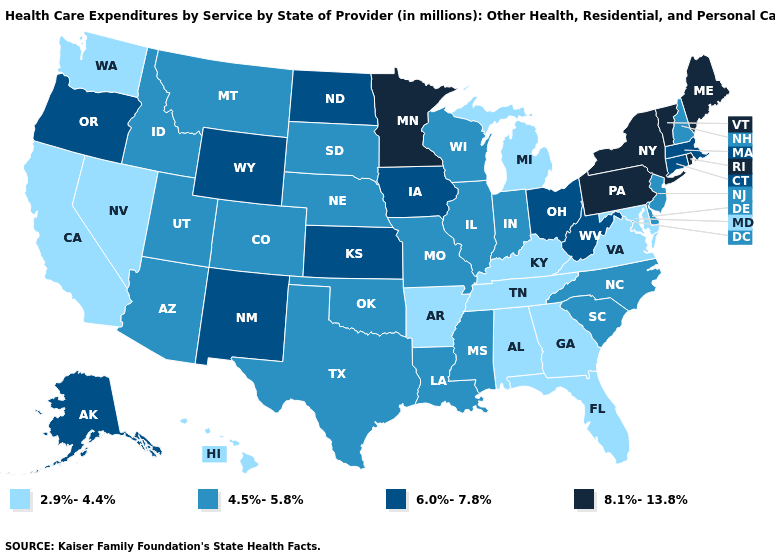What is the value of Hawaii?
Write a very short answer. 2.9%-4.4%. What is the value of Hawaii?
Quick response, please. 2.9%-4.4%. What is the value of North Carolina?
Be succinct. 4.5%-5.8%. Among the states that border California , does Arizona have the highest value?
Give a very brief answer. No. Does Arkansas have the lowest value in the USA?
Answer briefly. Yes. Does Florida have a lower value than Tennessee?
Give a very brief answer. No. Name the states that have a value in the range 8.1%-13.8%?
Quick response, please. Maine, Minnesota, New York, Pennsylvania, Rhode Island, Vermont. Name the states that have a value in the range 8.1%-13.8%?
Answer briefly. Maine, Minnesota, New York, Pennsylvania, Rhode Island, Vermont. What is the highest value in states that border New Jersey?
Keep it brief. 8.1%-13.8%. What is the value of Delaware?
Concise answer only. 4.5%-5.8%. What is the highest value in the USA?
Give a very brief answer. 8.1%-13.8%. What is the value of Colorado?
Concise answer only. 4.5%-5.8%. What is the value of Vermont?
Concise answer only. 8.1%-13.8%. Which states have the lowest value in the MidWest?
Be succinct. Michigan. Does Rhode Island have the highest value in the Northeast?
Concise answer only. Yes. 